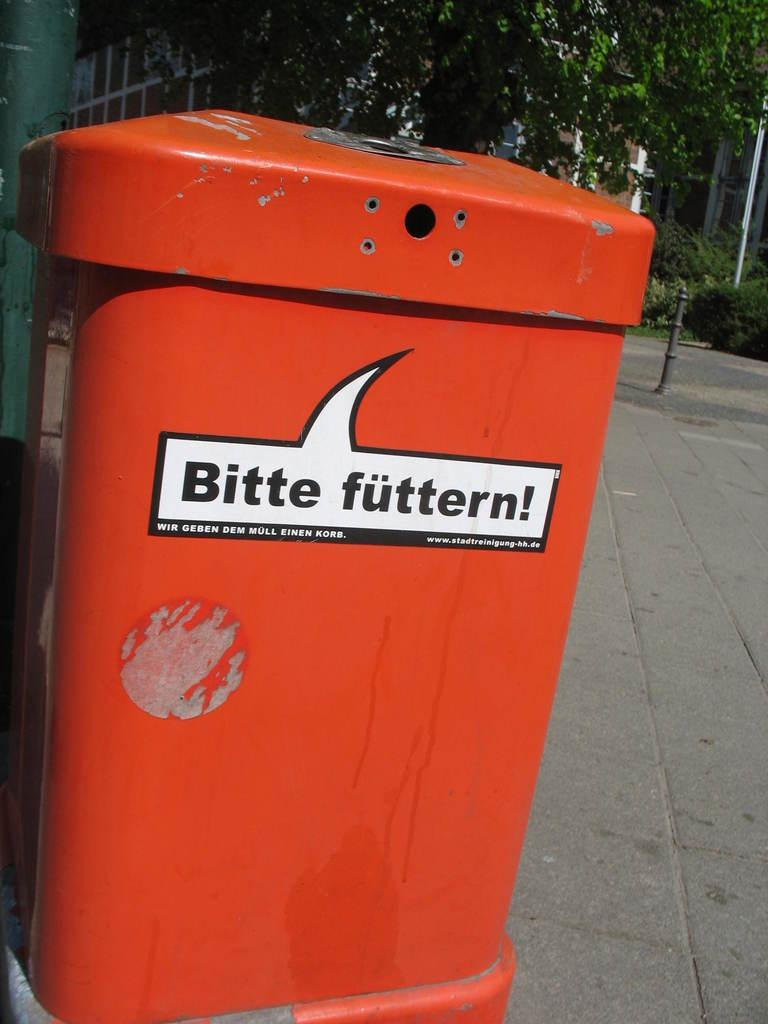<image>
Share a concise interpretation of the image provided. An orange bin reads "Bitte futtern" on the side. 